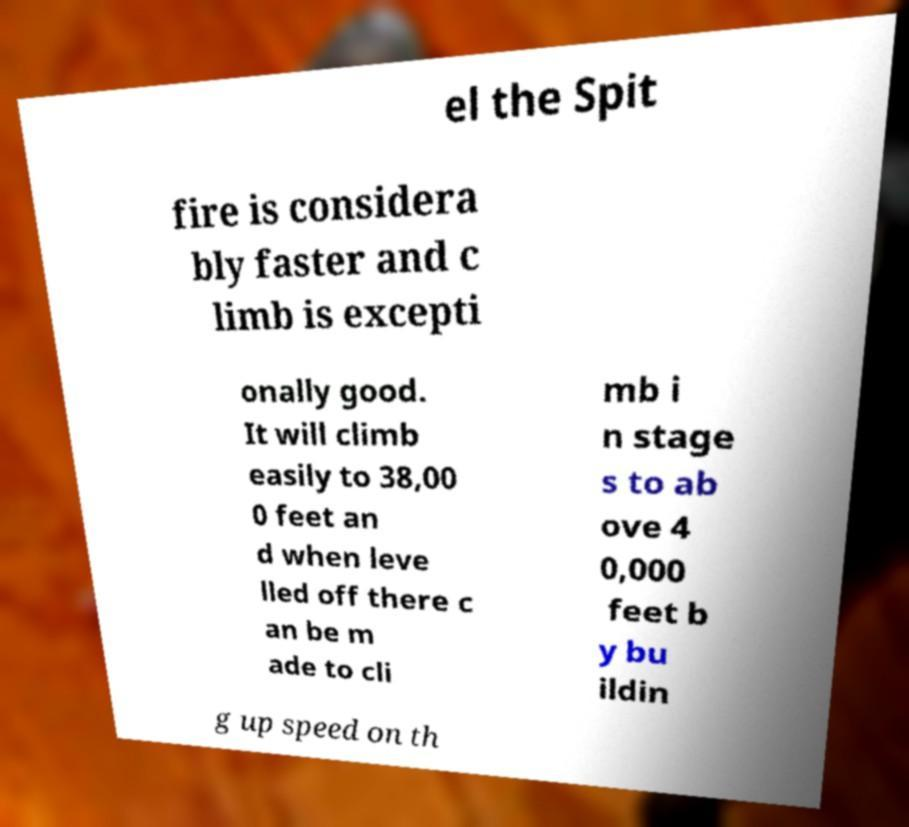For documentation purposes, I need the text within this image transcribed. Could you provide that? el the Spit fire is considera bly faster and c limb is excepti onally good. It will climb easily to 38,00 0 feet an d when leve lled off there c an be m ade to cli mb i n stage s to ab ove 4 0,000 feet b y bu ildin g up speed on th 